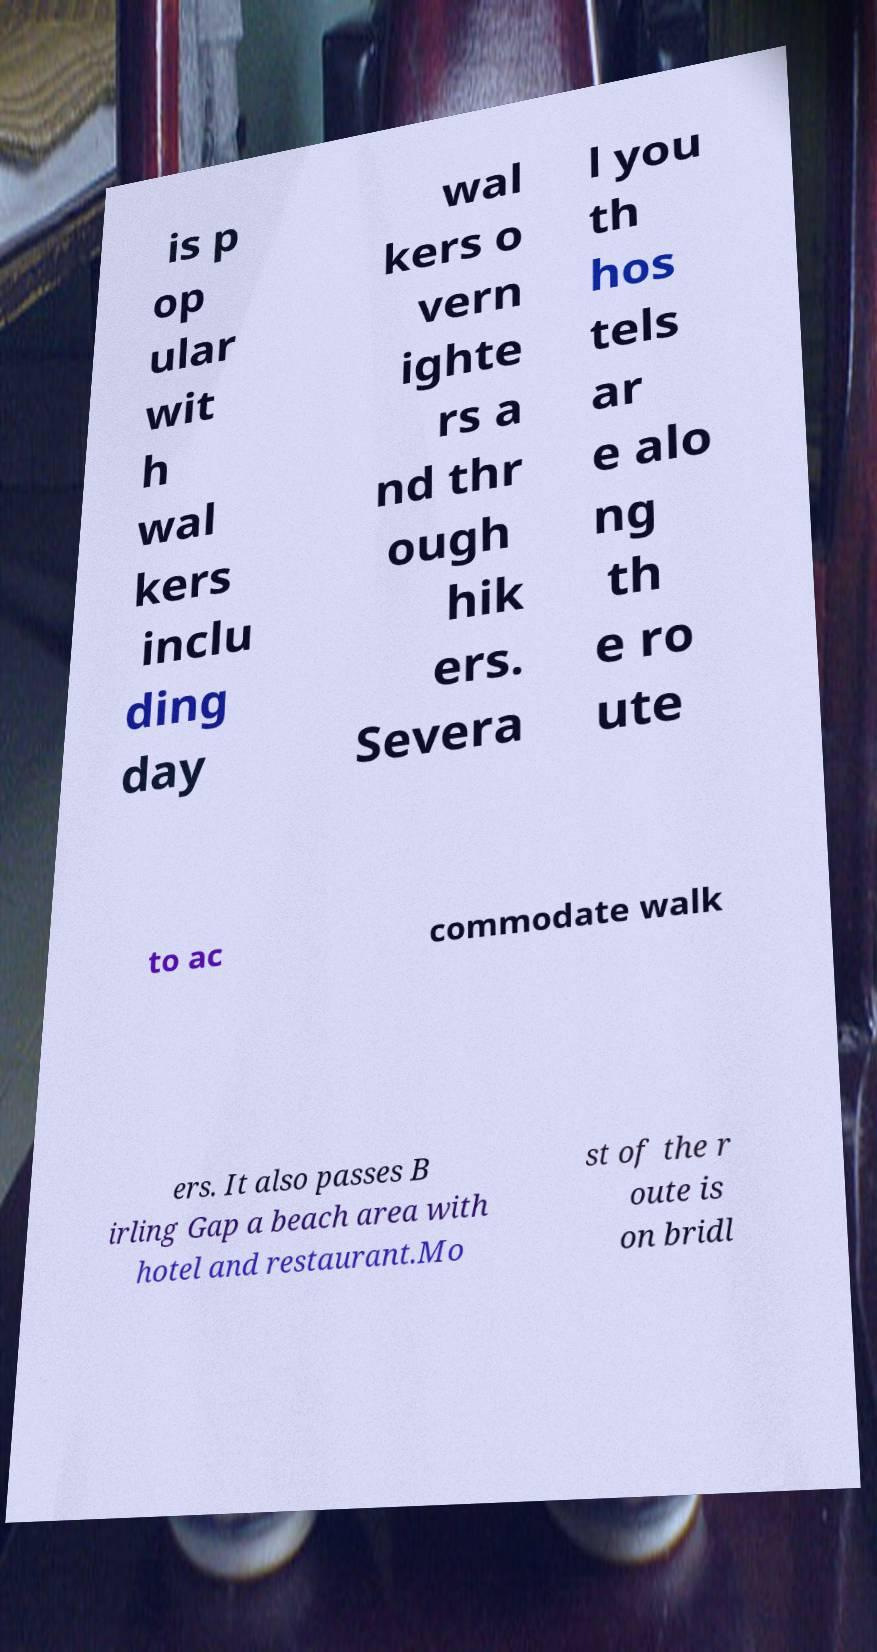Please read and relay the text visible in this image. What does it say? is p op ular wit h wal kers inclu ding day wal kers o vern ighte rs a nd thr ough hik ers. Severa l you th hos tels ar e alo ng th e ro ute to ac commodate walk ers. It also passes B irling Gap a beach area with hotel and restaurant.Mo st of the r oute is on bridl 